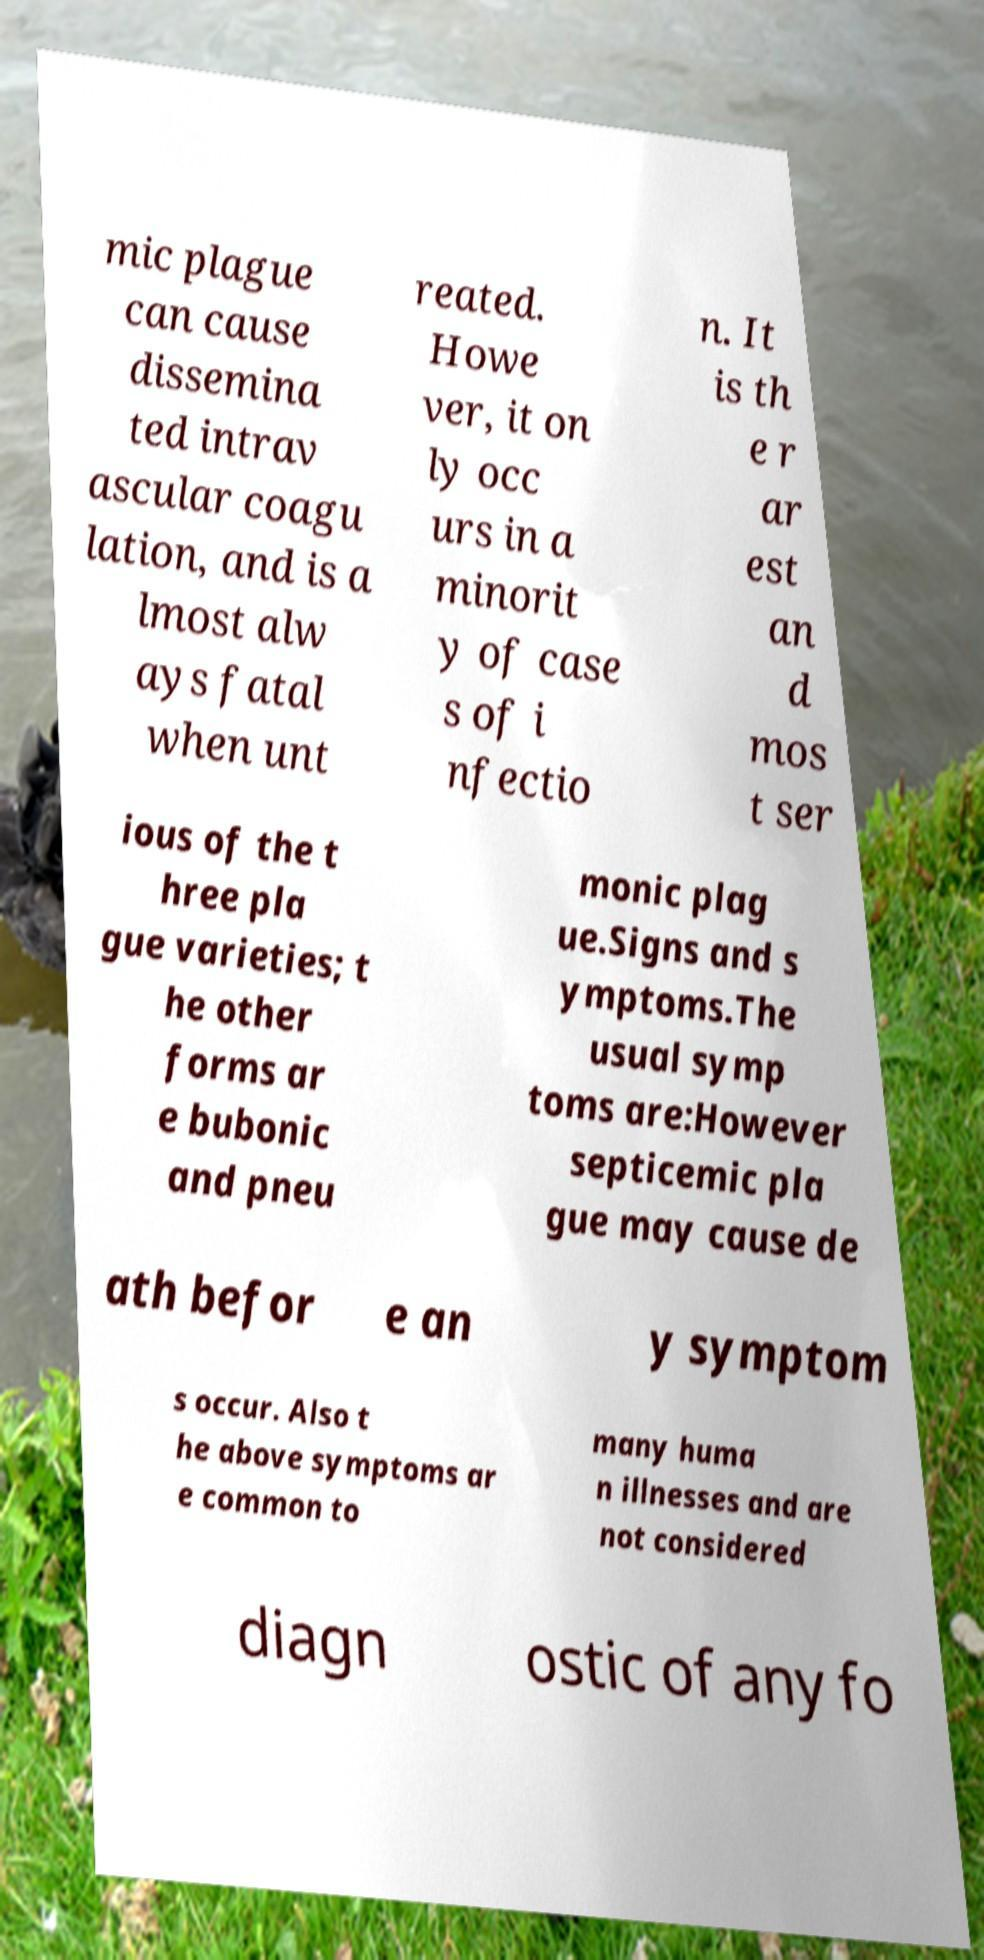I need the written content from this picture converted into text. Can you do that? mic plague can cause dissemina ted intrav ascular coagu lation, and is a lmost alw ays fatal when unt reated. Howe ver, it on ly occ urs in a minorit y of case s of i nfectio n. It is th e r ar est an d mos t ser ious of the t hree pla gue varieties; t he other forms ar e bubonic and pneu monic plag ue.Signs and s ymptoms.The usual symp toms are:However septicemic pla gue may cause de ath befor e an y symptom s occur. Also t he above symptoms ar e common to many huma n illnesses and are not considered diagn ostic of any fo 